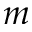<formula> <loc_0><loc_0><loc_500><loc_500>m</formula> 